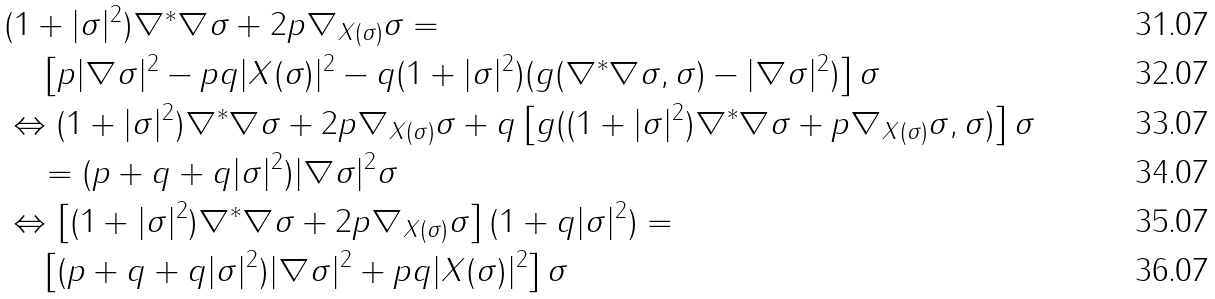<formula> <loc_0><loc_0><loc_500><loc_500>& ( 1 + | \sigma | ^ { 2 } ) \nabla ^ { * } \nabla \sigma + 2 p \nabla _ { X ( \sigma ) } \sigma = \\ & \quad \left [ p | \nabla \sigma | ^ { 2 } - p q | X ( \sigma ) | ^ { 2 } - q ( 1 + | \sigma | ^ { 2 } ) ( g ( \nabla ^ { * } \nabla \sigma , \sigma ) - | \nabla \sigma | ^ { 2 } ) \right ] \sigma \\ & \Leftrightarrow ( 1 + | \sigma | ^ { 2 } ) \nabla ^ { * } \nabla \sigma + 2 p \nabla _ { X ( \sigma ) } \sigma + q \left [ g ( ( 1 + | \sigma | ^ { 2 } ) \nabla ^ { * } \nabla \sigma + p \nabla _ { X ( \sigma ) } \sigma , \sigma ) \right ] \sigma \\ & \quad = ( p + q + q | \sigma | ^ { 2 } ) | \nabla \sigma | ^ { 2 } \sigma \\ & \Leftrightarrow \left [ ( 1 + | \sigma | ^ { 2 } ) \nabla ^ { * } \nabla \sigma + 2 p \nabla _ { X ( \sigma ) } \sigma \right ] ( 1 + q | \sigma | ^ { 2 } ) = \\ & \quad \left [ ( p + q + q | \sigma | ^ { 2 } ) | \nabla \sigma | ^ { 2 } + p q | X ( \sigma ) | ^ { 2 } \right ] \sigma</formula> 